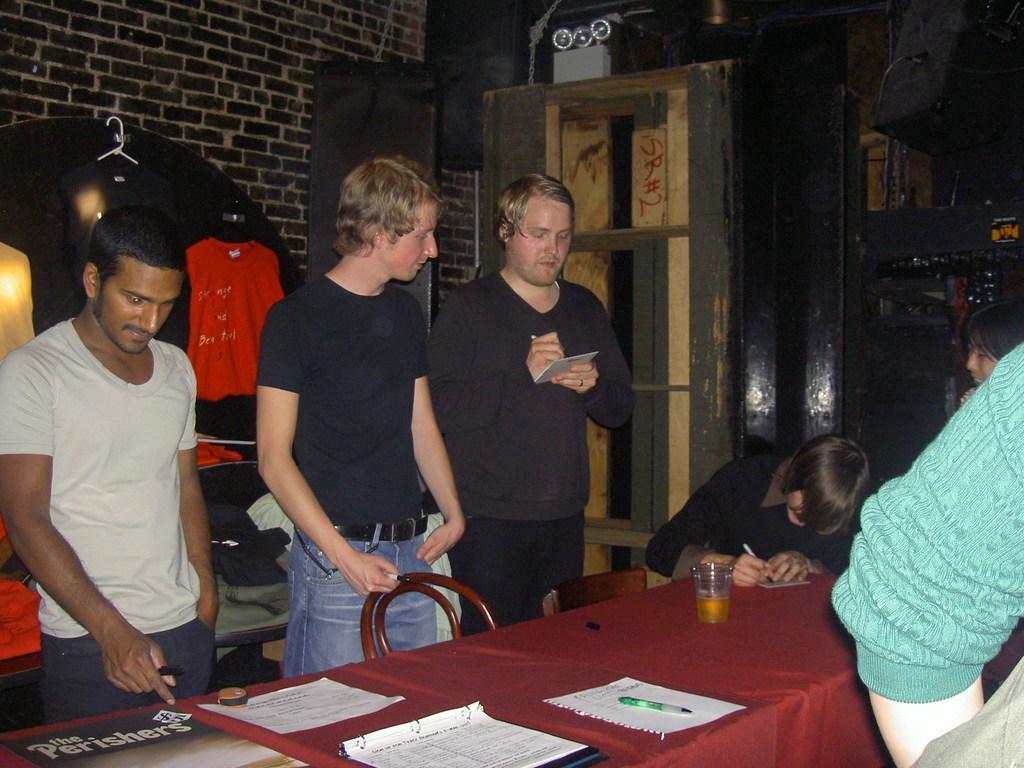Can you describe this image briefly? On the background of the picture we can see a wall with bricks. This is a door. here we can see few men standing in front of a table by holding marker and paper in their hands. and on the table we can see marker, papers, file and a glass of drink. Here we can see one man sitting and writing something on a paper with pen. this is a red shirt hanged over to the wall. This is a black shirt. 